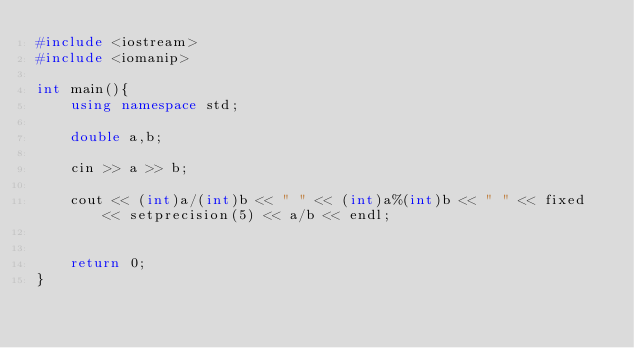Convert code to text. <code><loc_0><loc_0><loc_500><loc_500><_C++_>#include <iostream>
#include <iomanip>

int main(){
    using namespace std;
    
    double a,b;
    
    cin >> a >> b;
    
    cout << (int)a/(int)b << " " << (int)a%(int)b << " " << fixed << setprecision(5) << a/b << endl;
    
    
    return 0;
}</code> 